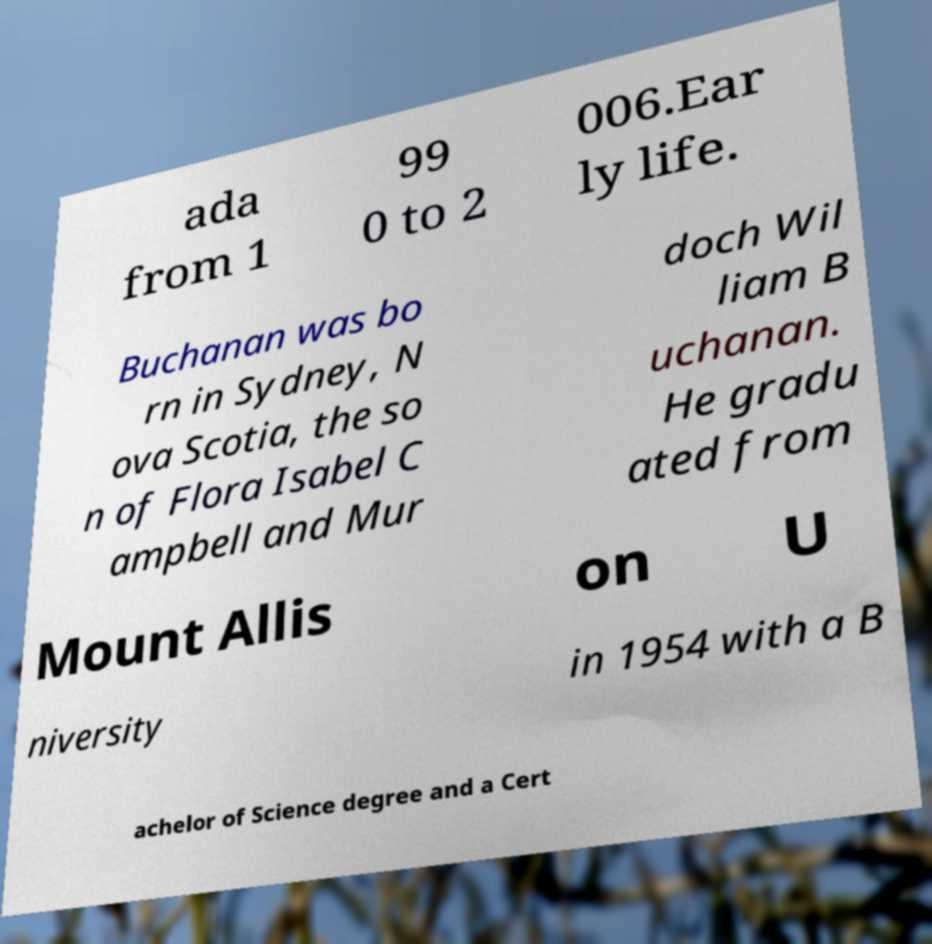For documentation purposes, I need the text within this image transcribed. Could you provide that? ada from 1 99 0 to 2 006.Ear ly life. Buchanan was bo rn in Sydney, N ova Scotia, the so n of Flora Isabel C ampbell and Mur doch Wil liam B uchanan. He gradu ated from Mount Allis on U niversity in 1954 with a B achelor of Science degree and a Cert 